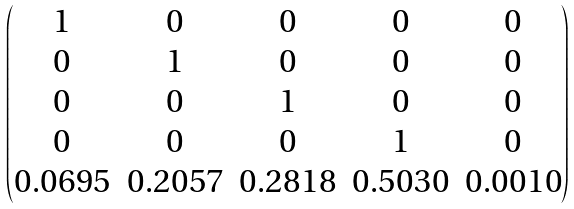Convert formula to latex. <formula><loc_0><loc_0><loc_500><loc_500>\begin{pmatrix} 1 & 0 & 0 & 0 & 0 \\ 0 & 1 & 0 & 0 & 0 \\ 0 & 0 & 1 & 0 & 0 \\ 0 & 0 & 0 & 1 & 0 \\ 0 . 0 6 9 5 & 0 . 2 0 5 7 & 0 . 2 8 1 8 & 0 . 5 0 3 0 & 0 . 0 0 1 0 \end{pmatrix}</formula> 